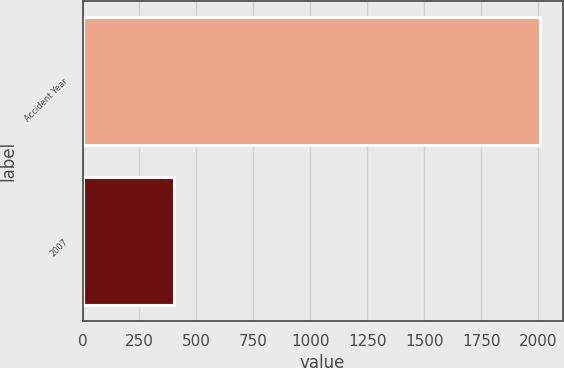Convert chart to OTSL. <chart><loc_0><loc_0><loc_500><loc_500><bar_chart><fcel>Accident Year<fcel>2007<nl><fcel>2007<fcel>402<nl></chart> 